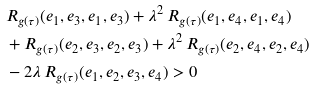<formula> <loc_0><loc_0><loc_500><loc_500>& R _ { g ( \tau ) } ( e _ { 1 } , e _ { 3 } , e _ { 1 } , e _ { 3 } ) + \lambda ^ { 2 } \, R _ { g ( \tau ) } ( e _ { 1 } , e _ { 4 } , e _ { 1 } , e _ { 4 } ) \\ & + R _ { g ( \tau ) } ( e _ { 2 } , e _ { 3 } , e _ { 2 } , e _ { 3 } ) + \lambda ^ { 2 } \, R _ { g ( \tau ) } ( e _ { 2 } , e _ { 4 } , e _ { 2 } , e _ { 4 } ) \\ & - 2 \lambda \, R _ { g ( \tau ) } ( e _ { 1 } , e _ { 2 } , e _ { 3 } , e _ { 4 } ) > 0</formula> 